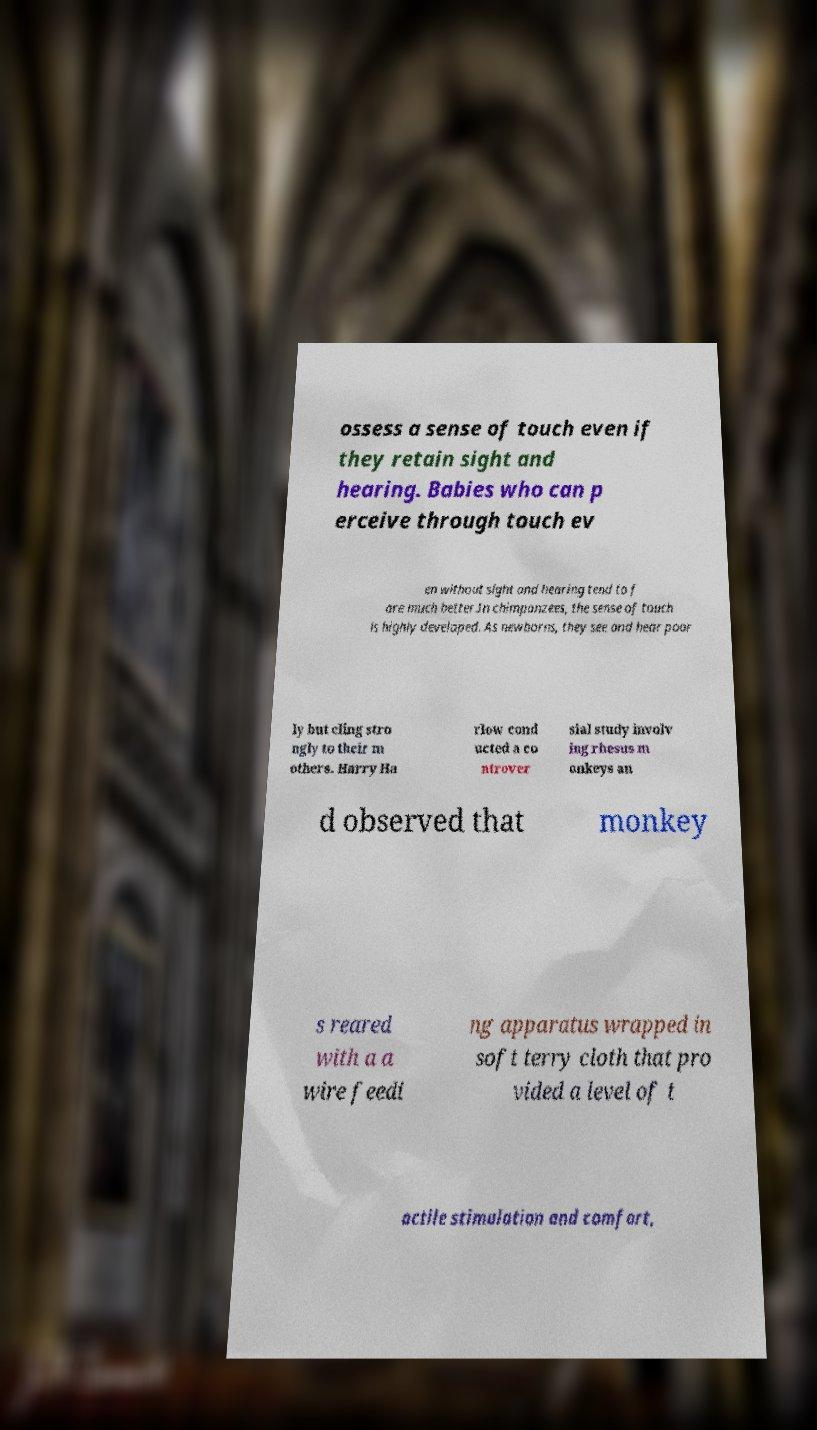Please read and relay the text visible in this image. What does it say? ossess a sense of touch even if they retain sight and hearing. Babies who can p erceive through touch ev en without sight and hearing tend to f are much better.In chimpanzees, the sense of touch is highly developed. As newborns, they see and hear poor ly but cling stro ngly to their m others. Harry Ha rlow cond ucted a co ntrover sial study involv ing rhesus m onkeys an d observed that monkey s reared with a a wire feedi ng apparatus wrapped in soft terry cloth that pro vided a level of t actile stimulation and comfort, 